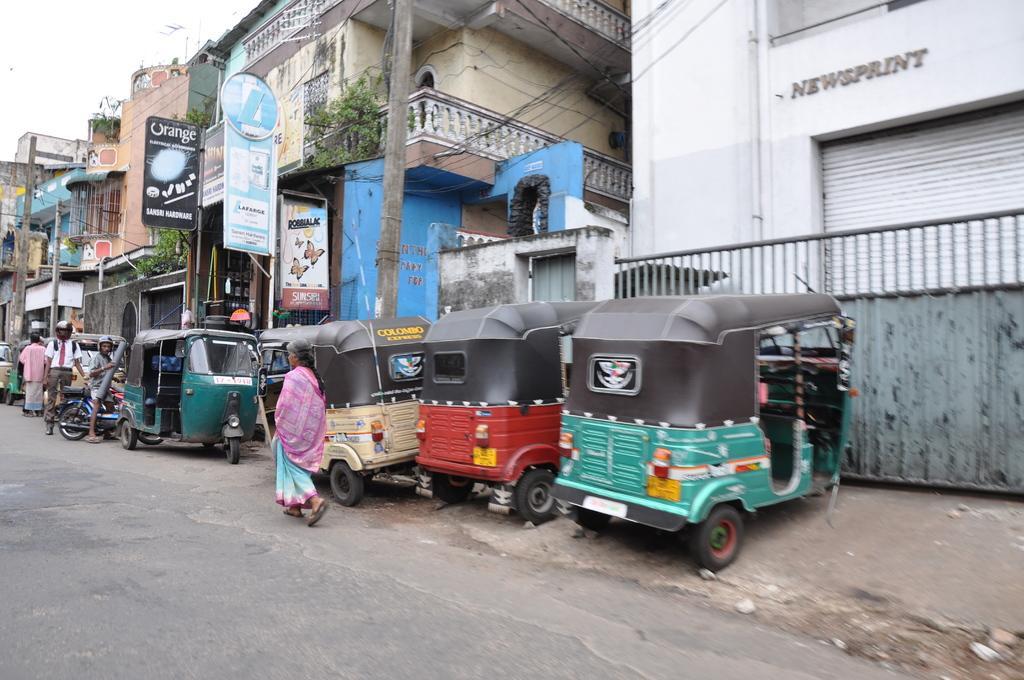Please provide a concise description of this image. In the foreground of this image, there is a road. In the middle, there are few people walking and standing on the road and a man on the motor bike. We can also see autos on the side path. Behind it, there are buildings, boards, greenery, poles, cables and the sky. 